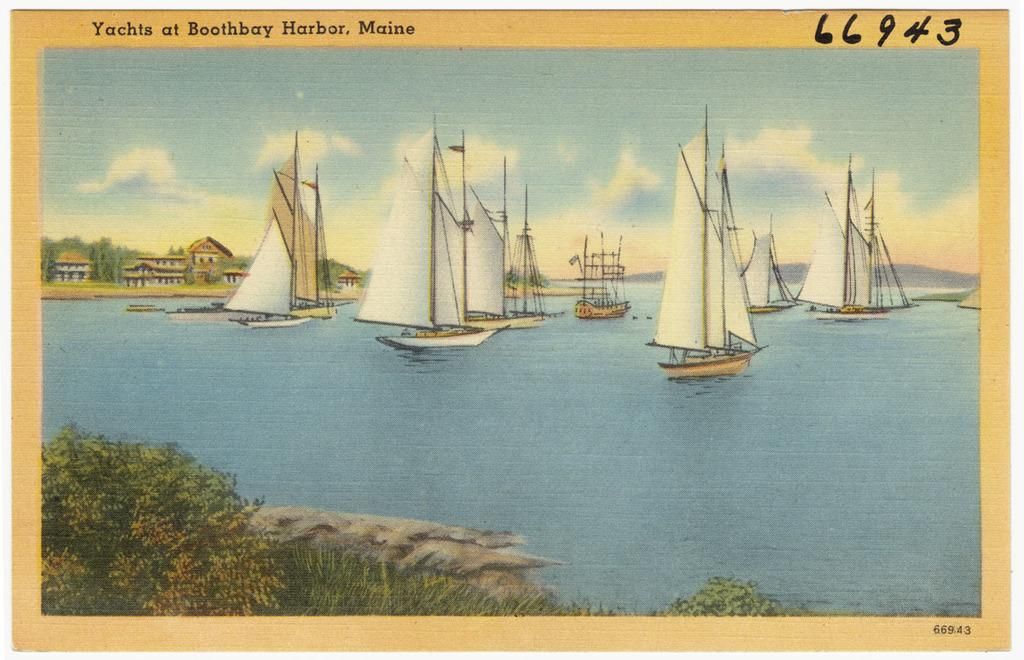<image>
Share a concise interpretation of the image provided. Several sailboats can be seen in the painting at Boothbay Harbor, Maine 